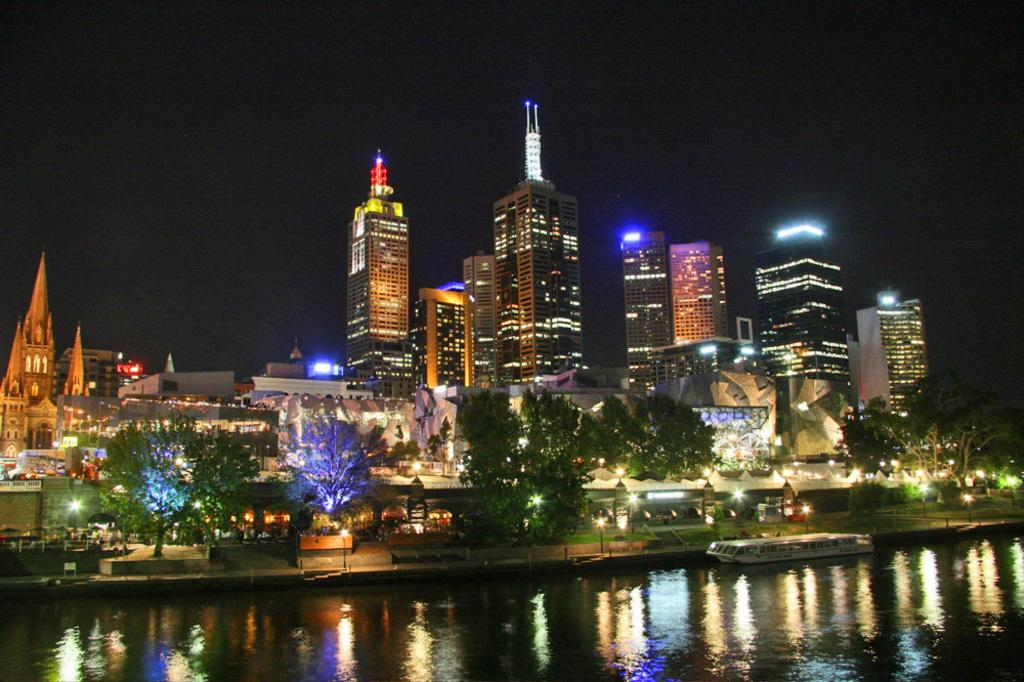What is visible in the image? Water is visible in the image. What can be seen in the background of the image? There are trees, lights, and buildings in the background of the image. What scent can be detected in the image? A: There is no information about any scent in the image, so it cannot be determined from the image. 